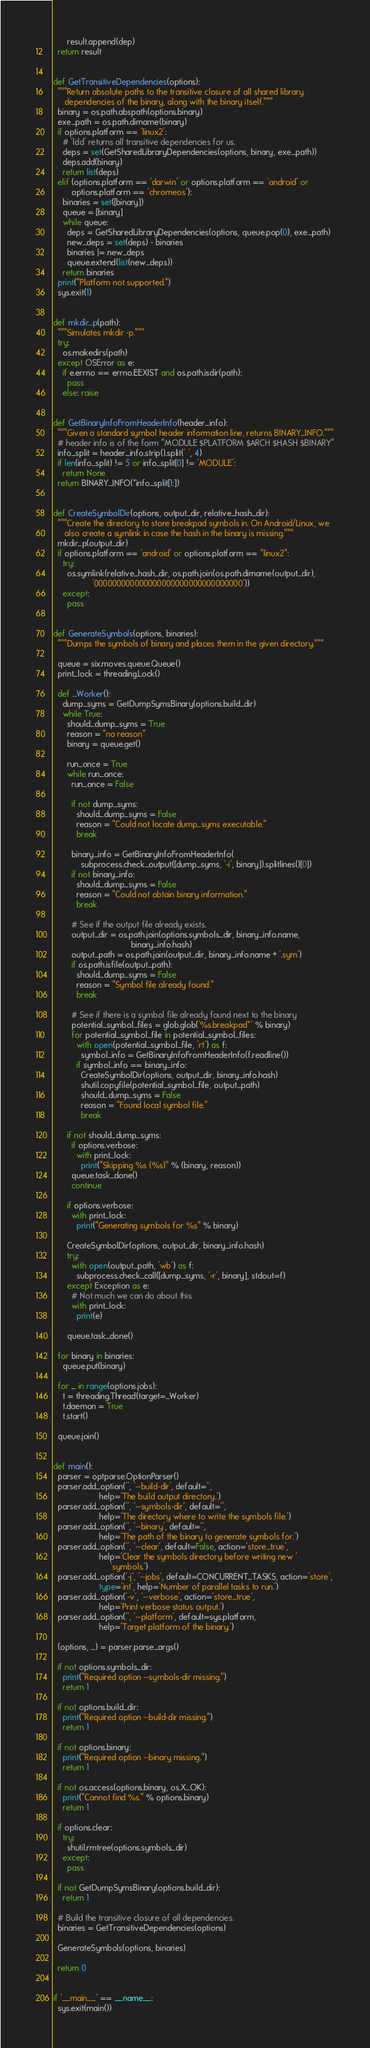Convert code to text. <code><loc_0><loc_0><loc_500><loc_500><_Python_>      result.append(dep)
  return result


def GetTransitiveDependencies(options):
  """Return absolute paths to the transitive closure of all shared library
     dependencies of the binary, along with the binary itself."""
  binary = os.path.abspath(options.binary)
  exe_path = os.path.dirname(binary)
  if options.platform == 'linux2':
    # 'ldd' returns all transitive dependencies for us.
    deps = set(GetSharedLibraryDependencies(options, binary, exe_path))
    deps.add(binary)
    return list(deps)
  elif (options.platform == 'darwin' or options.platform == 'android' or
        options.platform == 'chromeos'):
    binaries = set([binary])
    queue = [binary]
    while queue:
      deps = GetSharedLibraryDependencies(options, queue.pop(0), exe_path)
      new_deps = set(deps) - binaries
      binaries |= new_deps
      queue.extend(list(new_deps))
    return binaries
  print("Platform not supported.")
  sys.exit(1)


def mkdir_p(path):
  """Simulates mkdir -p."""
  try:
    os.makedirs(path)
  except OSError as e:
    if e.errno == errno.EEXIST and os.path.isdir(path):
      pass
    else: raise


def GetBinaryInfoFromHeaderInfo(header_info):
  """Given a standard symbol header information line, returns BINARY_INFO."""
  # header info is of the form "MODULE $PLATFORM $ARCH $HASH $BINARY"
  info_split = header_info.strip().split(' ', 4)
  if len(info_split) != 5 or info_split[0] != 'MODULE':
    return None
  return BINARY_INFO(*info_split[1:])


def CreateSymbolDir(options, output_dir, relative_hash_dir):
  """Create the directory to store breakpad symbols in. On Android/Linux, we
     also create a symlink in case the hash in the binary is missing."""
  mkdir_p(output_dir)
  if options.platform == 'android' or options.platform == "linux2":
    try:
      os.symlink(relative_hash_dir, os.path.join(os.path.dirname(output_dir),
                 '000000000000000000000000000000000'))
    except:
      pass


def GenerateSymbols(options, binaries):
  """Dumps the symbols of binary and places them in the given directory."""

  queue = six.moves.queue.Queue()
  print_lock = threading.Lock()

  def _Worker():
    dump_syms = GetDumpSymsBinary(options.build_dir)
    while True:
      should_dump_syms = True
      reason = "no reason"
      binary = queue.get()

      run_once = True
      while run_once:
        run_once = False

        if not dump_syms:
          should_dump_syms = False
          reason = "Could not locate dump_syms executable."
          break

        binary_info = GetBinaryInfoFromHeaderInfo(
            subprocess.check_output([dump_syms, '-i', binary]).splitlines()[0])
        if not binary_info:
          should_dump_syms = False
          reason = "Could not obtain binary information."
          break

        # See if the output file already exists.
        output_dir = os.path.join(options.symbols_dir, binary_info.name,
                                  binary_info.hash)
        output_path = os.path.join(output_dir, binary_info.name + '.sym')
        if os.path.isfile(output_path):
          should_dump_syms = False
          reason = "Symbol file already found."
          break

        # See if there is a symbol file already found next to the binary
        potential_symbol_files = glob.glob('%s.breakpad*' % binary)
        for potential_symbol_file in potential_symbol_files:
          with open(potential_symbol_file, 'rt') as f:
            symbol_info = GetBinaryInfoFromHeaderInfo(f.readline())
          if symbol_info == binary_info:
            CreateSymbolDir(options, output_dir, binary_info.hash)
            shutil.copyfile(potential_symbol_file, output_path)
            should_dump_syms = False
            reason = "Found local symbol file."
            break

      if not should_dump_syms:
        if options.verbose:
          with print_lock:
            print("Skipping %s (%s)" % (binary, reason))
        queue.task_done()
        continue

      if options.verbose:
        with print_lock:
          print("Generating symbols for %s" % binary)

      CreateSymbolDir(options, output_dir, binary_info.hash)
      try:
        with open(output_path, 'wb') as f:
          subprocess.check_call([dump_syms, '-r', binary], stdout=f)
      except Exception as e:
        # Not much we can do about this.
        with print_lock:
          print(e)

      queue.task_done()

  for binary in binaries:
    queue.put(binary)

  for _ in range(options.jobs):
    t = threading.Thread(target=_Worker)
    t.daemon = True
    t.start()

  queue.join()


def main():
  parser = optparse.OptionParser()
  parser.add_option('', '--build-dir', default='',
                    help='The build output directory.')
  parser.add_option('', '--symbols-dir', default='',
                    help='The directory where to write the symbols file.')
  parser.add_option('', '--binary', default='',
                    help='The path of the binary to generate symbols for.')
  parser.add_option('', '--clear', default=False, action='store_true',
                    help='Clear the symbols directory before writing new '
                         'symbols.')
  parser.add_option('-j', '--jobs', default=CONCURRENT_TASKS, action='store',
                    type='int', help='Number of parallel tasks to run.')
  parser.add_option('-v', '--verbose', action='store_true',
                    help='Print verbose status output.')
  parser.add_option('', '--platform', default=sys.platform,
                    help='Target platform of the binary.')

  (options, _) = parser.parse_args()

  if not options.symbols_dir:
    print("Required option --symbols-dir missing.")
    return 1

  if not options.build_dir:
    print("Required option --build-dir missing.")
    return 1

  if not options.binary:
    print("Required option --binary missing.")
    return 1

  if not os.access(options.binary, os.X_OK):
    print("Cannot find %s." % options.binary)
    return 1

  if options.clear:
    try:
      shutil.rmtree(options.symbols_dir)
    except:
      pass

  if not GetDumpSymsBinary(options.build_dir):
    return 1

  # Build the transitive closure of all dependencies.
  binaries = GetTransitiveDependencies(options)

  GenerateSymbols(options, binaries)

  return 0


if '__main__' == __name__:
  sys.exit(main())
</code> 